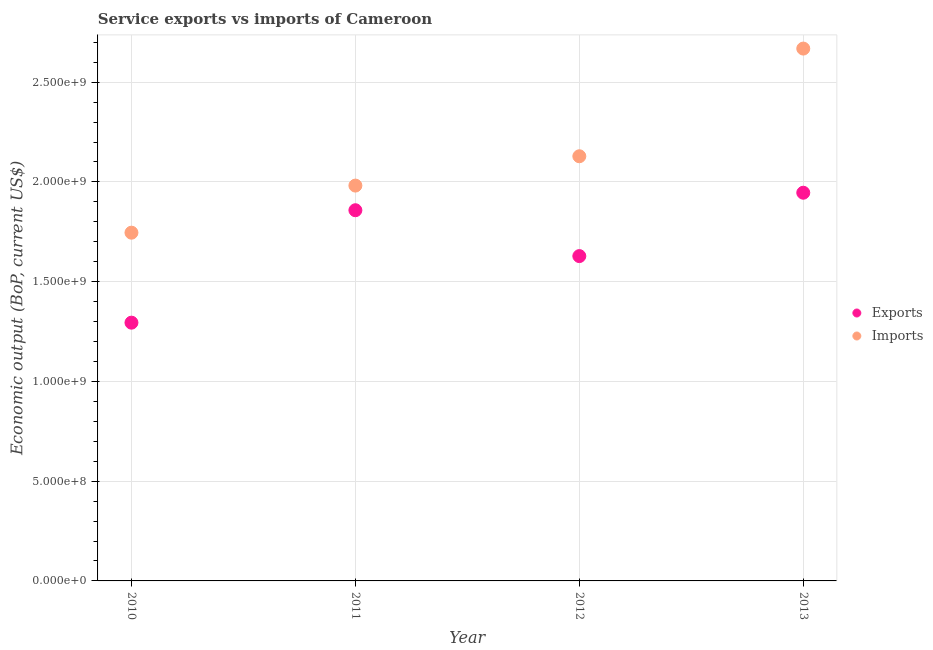How many different coloured dotlines are there?
Keep it short and to the point. 2. What is the amount of service imports in 2010?
Provide a succinct answer. 1.75e+09. Across all years, what is the maximum amount of service imports?
Keep it short and to the point. 2.67e+09. Across all years, what is the minimum amount of service imports?
Provide a short and direct response. 1.75e+09. In which year was the amount of service exports maximum?
Give a very brief answer. 2013. What is the total amount of service imports in the graph?
Your answer should be very brief. 8.52e+09. What is the difference between the amount of service imports in 2010 and that in 2012?
Your response must be concise. -3.83e+08. What is the difference between the amount of service imports in 2010 and the amount of service exports in 2013?
Your answer should be very brief. -2.00e+08. What is the average amount of service imports per year?
Your answer should be compact. 2.13e+09. In the year 2012, what is the difference between the amount of service imports and amount of service exports?
Make the answer very short. 5.00e+08. What is the ratio of the amount of service exports in 2011 to that in 2012?
Make the answer very short. 1.14. Is the amount of service imports in 2010 less than that in 2011?
Your answer should be very brief. Yes. What is the difference between the highest and the second highest amount of service imports?
Offer a very short reply. 5.40e+08. What is the difference between the highest and the lowest amount of service exports?
Your response must be concise. 6.51e+08. Does the amount of service exports monotonically increase over the years?
Provide a succinct answer. No. How many dotlines are there?
Provide a succinct answer. 2. How many years are there in the graph?
Provide a short and direct response. 4. How many legend labels are there?
Ensure brevity in your answer.  2. What is the title of the graph?
Offer a terse response. Service exports vs imports of Cameroon. Does "Not attending school" appear as one of the legend labels in the graph?
Give a very brief answer. No. What is the label or title of the Y-axis?
Provide a short and direct response. Economic output (BoP, current US$). What is the Economic output (BoP, current US$) in Exports in 2010?
Ensure brevity in your answer.  1.29e+09. What is the Economic output (BoP, current US$) in Imports in 2010?
Your response must be concise. 1.75e+09. What is the Economic output (BoP, current US$) of Exports in 2011?
Ensure brevity in your answer.  1.86e+09. What is the Economic output (BoP, current US$) of Imports in 2011?
Give a very brief answer. 1.98e+09. What is the Economic output (BoP, current US$) of Exports in 2012?
Keep it short and to the point. 1.63e+09. What is the Economic output (BoP, current US$) of Imports in 2012?
Provide a succinct answer. 2.13e+09. What is the Economic output (BoP, current US$) of Exports in 2013?
Offer a very short reply. 1.95e+09. What is the Economic output (BoP, current US$) in Imports in 2013?
Your response must be concise. 2.67e+09. Across all years, what is the maximum Economic output (BoP, current US$) of Exports?
Keep it short and to the point. 1.95e+09. Across all years, what is the maximum Economic output (BoP, current US$) in Imports?
Your response must be concise. 2.67e+09. Across all years, what is the minimum Economic output (BoP, current US$) of Exports?
Make the answer very short. 1.29e+09. Across all years, what is the minimum Economic output (BoP, current US$) of Imports?
Make the answer very short. 1.75e+09. What is the total Economic output (BoP, current US$) of Exports in the graph?
Ensure brevity in your answer.  6.73e+09. What is the total Economic output (BoP, current US$) of Imports in the graph?
Give a very brief answer. 8.52e+09. What is the difference between the Economic output (BoP, current US$) of Exports in 2010 and that in 2011?
Ensure brevity in your answer.  -5.64e+08. What is the difference between the Economic output (BoP, current US$) of Imports in 2010 and that in 2011?
Your response must be concise. -2.36e+08. What is the difference between the Economic output (BoP, current US$) in Exports in 2010 and that in 2012?
Keep it short and to the point. -3.34e+08. What is the difference between the Economic output (BoP, current US$) of Imports in 2010 and that in 2012?
Provide a succinct answer. -3.83e+08. What is the difference between the Economic output (BoP, current US$) in Exports in 2010 and that in 2013?
Your response must be concise. -6.51e+08. What is the difference between the Economic output (BoP, current US$) in Imports in 2010 and that in 2013?
Ensure brevity in your answer.  -9.23e+08. What is the difference between the Economic output (BoP, current US$) in Exports in 2011 and that in 2012?
Keep it short and to the point. 2.30e+08. What is the difference between the Economic output (BoP, current US$) in Imports in 2011 and that in 2012?
Your answer should be compact. -1.47e+08. What is the difference between the Economic output (BoP, current US$) of Exports in 2011 and that in 2013?
Keep it short and to the point. -8.78e+07. What is the difference between the Economic output (BoP, current US$) of Imports in 2011 and that in 2013?
Make the answer very short. -6.87e+08. What is the difference between the Economic output (BoP, current US$) of Exports in 2012 and that in 2013?
Your answer should be very brief. -3.18e+08. What is the difference between the Economic output (BoP, current US$) of Imports in 2012 and that in 2013?
Your answer should be compact. -5.40e+08. What is the difference between the Economic output (BoP, current US$) in Exports in 2010 and the Economic output (BoP, current US$) in Imports in 2011?
Your answer should be very brief. -6.87e+08. What is the difference between the Economic output (BoP, current US$) of Exports in 2010 and the Economic output (BoP, current US$) of Imports in 2012?
Your answer should be very brief. -8.34e+08. What is the difference between the Economic output (BoP, current US$) of Exports in 2010 and the Economic output (BoP, current US$) of Imports in 2013?
Give a very brief answer. -1.37e+09. What is the difference between the Economic output (BoP, current US$) of Exports in 2011 and the Economic output (BoP, current US$) of Imports in 2012?
Keep it short and to the point. -2.71e+08. What is the difference between the Economic output (BoP, current US$) of Exports in 2011 and the Economic output (BoP, current US$) of Imports in 2013?
Provide a succinct answer. -8.10e+08. What is the difference between the Economic output (BoP, current US$) of Exports in 2012 and the Economic output (BoP, current US$) of Imports in 2013?
Give a very brief answer. -1.04e+09. What is the average Economic output (BoP, current US$) of Exports per year?
Your answer should be compact. 1.68e+09. What is the average Economic output (BoP, current US$) in Imports per year?
Your response must be concise. 2.13e+09. In the year 2010, what is the difference between the Economic output (BoP, current US$) in Exports and Economic output (BoP, current US$) in Imports?
Your answer should be compact. -4.51e+08. In the year 2011, what is the difference between the Economic output (BoP, current US$) in Exports and Economic output (BoP, current US$) in Imports?
Offer a very short reply. -1.24e+08. In the year 2012, what is the difference between the Economic output (BoP, current US$) of Exports and Economic output (BoP, current US$) of Imports?
Your response must be concise. -5.00e+08. In the year 2013, what is the difference between the Economic output (BoP, current US$) in Exports and Economic output (BoP, current US$) in Imports?
Offer a terse response. -7.23e+08. What is the ratio of the Economic output (BoP, current US$) of Exports in 2010 to that in 2011?
Provide a succinct answer. 0.7. What is the ratio of the Economic output (BoP, current US$) in Imports in 2010 to that in 2011?
Provide a succinct answer. 0.88. What is the ratio of the Economic output (BoP, current US$) in Exports in 2010 to that in 2012?
Make the answer very short. 0.8. What is the ratio of the Economic output (BoP, current US$) of Imports in 2010 to that in 2012?
Your response must be concise. 0.82. What is the ratio of the Economic output (BoP, current US$) in Exports in 2010 to that in 2013?
Keep it short and to the point. 0.67. What is the ratio of the Economic output (BoP, current US$) of Imports in 2010 to that in 2013?
Offer a very short reply. 0.65. What is the ratio of the Economic output (BoP, current US$) of Exports in 2011 to that in 2012?
Provide a short and direct response. 1.14. What is the ratio of the Economic output (BoP, current US$) in Imports in 2011 to that in 2012?
Offer a terse response. 0.93. What is the ratio of the Economic output (BoP, current US$) of Exports in 2011 to that in 2013?
Make the answer very short. 0.95. What is the ratio of the Economic output (BoP, current US$) in Imports in 2011 to that in 2013?
Keep it short and to the point. 0.74. What is the ratio of the Economic output (BoP, current US$) in Exports in 2012 to that in 2013?
Offer a very short reply. 0.84. What is the ratio of the Economic output (BoP, current US$) in Imports in 2012 to that in 2013?
Your response must be concise. 0.8. What is the difference between the highest and the second highest Economic output (BoP, current US$) of Exports?
Your answer should be very brief. 8.78e+07. What is the difference between the highest and the second highest Economic output (BoP, current US$) in Imports?
Give a very brief answer. 5.40e+08. What is the difference between the highest and the lowest Economic output (BoP, current US$) of Exports?
Make the answer very short. 6.51e+08. What is the difference between the highest and the lowest Economic output (BoP, current US$) in Imports?
Keep it short and to the point. 9.23e+08. 